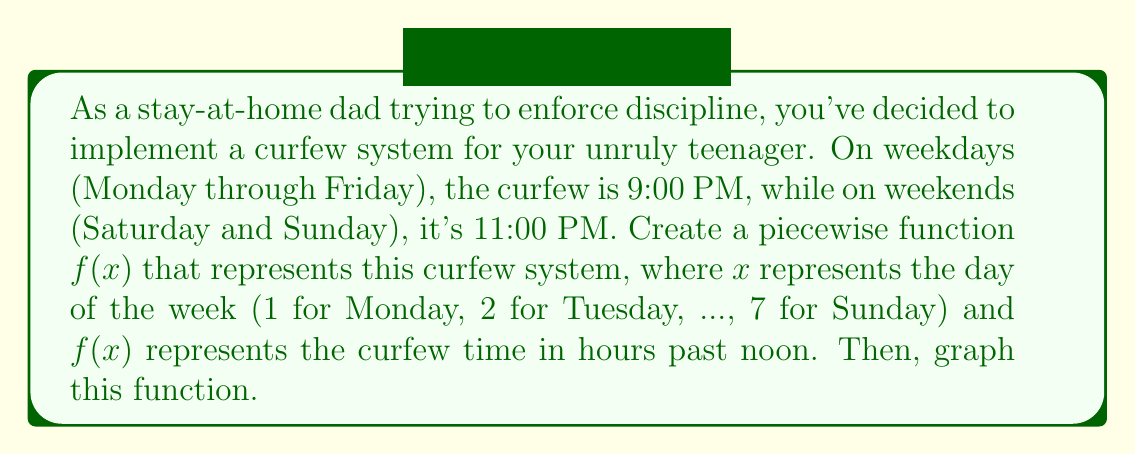Show me your answer to this math problem. To solve this problem, let's follow these steps:

1. Define the piecewise function:
   $$f(x) = \begin{cases}
   9, & 1 \leq x \leq 5 \\
   11, & 6 \leq x \leq 7
   \end{cases}$$

   Here, 9 represents 9:00 PM (9 hours past noon) for weekdays, and 11 represents 11:00 PM (11 hours past noon) for weekends.

2. To graph this function, we'll use a coordinate plane where:
   - The x-axis represents the days of the week (1 to 7)
   - The y-axis represents the curfew time in hours past noon

3. Plot the points:
   - For x = 1 to 5 (Monday to Friday), plot points at y = 9
   - For x = 6 to 7 (Saturday and Sunday), plot points at y = 11

4. Connect the points with horizontal line segments:
   - A line segment at y = 9 from x = 1 to x = 5
   - A line segment at y = 11 from x = 6 to x = 7

5. Add open circles at (5, 9) and (6, 11) to show the function is discontinuous at these points.

Here's the graph using Asymptote:

[asy]
import graph;
size(200,150);

// Set up the axes
xaxis("Day of the week", 0, 8, Arrow);
yaxis("Curfew time (hours past noon)", 0, 12, Arrow);

// Plot the function
draw((1,9)--(5,9), blue);
draw((6,11)--(7,11), blue);

// Add open circles for discontinuities
dot((5,9), white);
dot((6,11), white);
draw(circle((5,9),0.05), blue);
draw(circle((6,11),0.05), blue);

// Label the days of the week
for(int i=1; i <= 7; ++i) {
  label(string(i), (i,0), S);
}

// Label the curfew times
label("9 PM", (3,9), N);
label("11 PM", (6.5,11), N);
[/asy]
Answer: The piecewise function representing the curfew system is:

$$f(x) = \begin{cases}
9, & 1 \leq x \leq 5 \\
11, & 6 \leq x \leq 7
\end{cases}$$

The graph is a step function with two horizontal line segments: one at y = 9 from x = 1 to x = 5, and another at y = 11 from x = 6 to x = 7, with open circles at (5, 9) and (6, 11) to indicate discontinuities. 